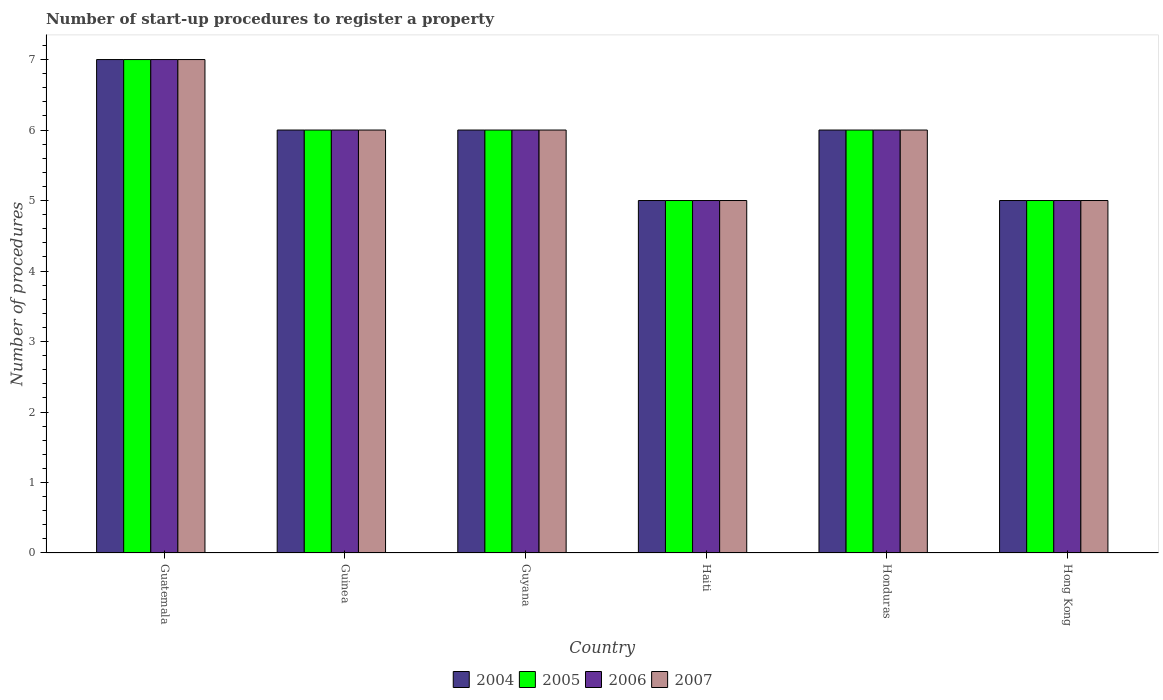How many different coloured bars are there?
Your answer should be very brief. 4. How many groups of bars are there?
Offer a very short reply. 6. Are the number of bars per tick equal to the number of legend labels?
Your answer should be compact. Yes. What is the label of the 5th group of bars from the left?
Provide a short and direct response. Honduras. In how many cases, is the number of bars for a given country not equal to the number of legend labels?
Your answer should be compact. 0. What is the number of procedures required to register a property in 2006 in Guyana?
Your response must be concise. 6. Across all countries, what is the minimum number of procedures required to register a property in 2007?
Your response must be concise. 5. In which country was the number of procedures required to register a property in 2004 maximum?
Make the answer very short. Guatemala. In which country was the number of procedures required to register a property in 2005 minimum?
Your response must be concise. Haiti. What is the average number of procedures required to register a property in 2004 per country?
Keep it short and to the point. 5.83. What is the difference between the number of procedures required to register a property of/in 2007 and number of procedures required to register a property of/in 2004 in Guyana?
Give a very brief answer. 0. What is the ratio of the number of procedures required to register a property in 2006 in Guyana to that in Haiti?
Make the answer very short. 1.2. Is the number of procedures required to register a property in 2007 in Haiti less than that in Hong Kong?
Keep it short and to the point. No. Is the difference between the number of procedures required to register a property in 2007 in Guinea and Honduras greater than the difference between the number of procedures required to register a property in 2004 in Guinea and Honduras?
Offer a terse response. No. Is the sum of the number of procedures required to register a property in 2006 in Guatemala and Hong Kong greater than the maximum number of procedures required to register a property in 2007 across all countries?
Provide a succinct answer. Yes. Is it the case that in every country, the sum of the number of procedures required to register a property in 2006 and number of procedures required to register a property in 2004 is greater than the sum of number of procedures required to register a property in 2007 and number of procedures required to register a property in 2005?
Your answer should be very brief. No. Are all the bars in the graph horizontal?
Your answer should be very brief. No. Does the graph contain any zero values?
Ensure brevity in your answer.  No. Does the graph contain grids?
Provide a short and direct response. No. Where does the legend appear in the graph?
Offer a terse response. Bottom center. How are the legend labels stacked?
Provide a succinct answer. Horizontal. What is the title of the graph?
Your response must be concise. Number of start-up procedures to register a property. What is the label or title of the Y-axis?
Provide a succinct answer. Number of procedures. What is the Number of procedures of 2005 in Guatemala?
Make the answer very short. 7. What is the Number of procedures of 2006 in Guatemala?
Provide a short and direct response. 7. What is the Number of procedures in 2004 in Guinea?
Your answer should be very brief. 6. What is the Number of procedures of 2005 in Guinea?
Keep it short and to the point. 6. What is the Number of procedures of 2006 in Guinea?
Your response must be concise. 6. What is the Number of procedures of 2007 in Guinea?
Keep it short and to the point. 6. What is the Number of procedures of 2005 in Guyana?
Offer a terse response. 6. What is the Number of procedures of 2006 in Guyana?
Your answer should be compact. 6. What is the Number of procedures of 2004 in Haiti?
Offer a terse response. 5. What is the Number of procedures of 2006 in Haiti?
Provide a short and direct response. 5. What is the Number of procedures of 2007 in Haiti?
Your answer should be compact. 5. What is the Number of procedures in 2006 in Honduras?
Provide a succinct answer. 6. What is the Number of procedures in 2005 in Hong Kong?
Your response must be concise. 5. What is the Number of procedures in 2007 in Hong Kong?
Offer a very short reply. 5. Across all countries, what is the maximum Number of procedures in 2004?
Offer a very short reply. 7. Across all countries, what is the maximum Number of procedures of 2005?
Offer a very short reply. 7. Across all countries, what is the maximum Number of procedures of 2006?
Offer a very short reply. 7. Across all countries, what is the maximum Number of procedures in 2007?
Offer a terse response. 7. Across all countries, what is the minimum Number of procedures of 2006?
Give a very brief answer. 5. What is the total Number of procedures in 2004 in the graph?
Your answer should be compact. 35. What is the total Number of procedures of 2005 in the graph?
Offer a terse response. 35. What is the difference between the Number of procedures of 2004 in Guatemala and that in Guinea?
Provide a short and direct response. 1. What is the difference between the Number of procedures of 2005 in Guatemala and that in Guinea?
Provide a short and direct response. 1. What is the difference between the Number of procedures in 2006 in Guatemala and that in Guinea?
Offer a very short reply. 1. What is the difference between the Number of procedures of 2007 in Guatemala and that in Guinea?
Provide a short and direct response. 1. What is the difference between the Number of procedures of 2005 in Guatemala and that in Guyana?
Your response must be concise. 1. What is the difference between the Number of procedures in 2006 in Guatemala and that in Guyana?
Provide a succinct answer. 1. What is the difference between the Number of procedures of 2006 in Guatemala and that in Haiti?
Your answer should be very brief. 2. What is the difference between the Number of procedures in 2007 in Guatemala and that in Haiti?
Offer a terse response. 2. What is the difference between the Number of procedures of 2004 in Guatemala and that in Honduras?
Offer a very short reply. 1. What is the difference between the Number of procedures in 2005 in Guatemala and that in Honduras?
Offer a very short reply. 1. What is the difference between the Number of procedures in 2006 in Guatemala and that in Honduras?
Your answer should be compact. 1. What is the difference between the Number of procedures of 2007 in Guatemala and that in Honduras?
Your answer should be very brief. 1. What is the difference between the Number of procedures of 2005 in Guatemala and that in Hong Kong?
Provide a succinct answer. 2. What is the difference between the Number of procedures in 2006 in Guatemala and that in Hong Kong?
Ensure brevity in your answer.  2. What is the difference between the Number of procedures in 2007 in Guatemala and that in Hong Kong?
Provide a short and direct response. 2. What is the difference between the Number of procedures of 2004 in Guinea and that in Guyana?
Your response must be concise. 0. What is the difference between the Number of procedures in 2005 in Guinea and that in Guyana?
Offer a very short reply. 0. What is the difference between the Number of procedures of 2007 in Guinea and that in Guyana?
Provide a short and direct response. 0. What is the difference between the Number of procedures of 2007 in Guinea and that in Haiti?
Offer a very short reply. 1. What is the difference between the Number of procedures of 2004 in Guinea and that in Honduras?
Your answer should be compact. 0. What is the difference between the Number of procedures of 2005 in Guinea and that in Honduras?
Your answer should be very brief. 0. What is the difference between the Number of procedures of 2006 in Guinea and that in Honduras?
Give a very brief answer. 0. What is the difference between the Number of procedures of 2005 in Guinea and that in Hong Kong?
Give a very brief answer. 1. What is the difference between the Number of procedures of 2005 in Guyana and that in Haiti?
Offer a terse response. 1. What is the difference between the Number of procedures in 2006 in Guyana and that in Haiti?
Your answer should be compact. 1. What is the difference between the Number of procedures of 2007 in Guyana and that in Haiti?
Offer a very short reply. 1. What is the difference between the Number of procedures of 2006 in Guyana and that in Honduras?
Provide a succinct answer. 0. What is the difference between the Number of procedures in 2004 in Guyana and that in Hong Kong?
Provide a short and direct response. 1. What is the difference between the Number of procedures of 2004 in Haiti and that in Honduras?
Make the answer very short. -1. What is the difference between the Number of procedures in 2005 in Haiti and that in Honduras?
Your response must be concise. -1. What is the difference between the Number of procedures of 2007 in Haiti and that in Hong Kong?
Provide a short and direct response. 0. What is the difference between the Number of procedures in 2004 in Honduras and that in Hong Kong?
Provide a succinct answer. 1. What is the difference between the Number of procedures in 2006 in Honduras and that in Hong Kong?
Your answer should be very brief. 1. What is the difference between the Number of procedures of 2007 in Honduras and that in Hong Kong?
Provide a succinct answer. 1. What is the difference between the Number of procedures in 2004 in Guatemala and the Number of procedures in 2006 in Guinea?
Keep it short and to the point. 1. What is the difference between the Number of procedures in 2005 in Guatemala and the Number of procedures in 2006 in Guinea?
Offer a terse response. 1. What is the difference between the Number of procedures in 2004 in Guatemala and the Number of procedures in 2005 in Guyana?
Ensure brevity in your answer.  1. What is the difference between the Number of procedures in 2005 in Guatemala and the Number of procedures in 2007 in Guyana?
Your answer should be very brief. 1. What is the difference between the Number of procedures in 2006 in Guatemala and the Number of procedures in 2007 in Guyana?
Provide a succinct answer. 1. What is the difference between the Number of procedures in 2004 in Guatemala and the Number of procedures in 2006 in Haiti?
Make the answer very short. 2. What is the difference between the Number of procedures in 2004 in Guatemala and the Number of procedures in 2007 in Haiti?
Ensure brevity in your answer.  2. What is the difference between the Number of procedures in 2005 in Guatemala and the Number of procedures in 2007 in Haiti?
Make the answer very short. 2. What is the difference between the Number of procedures in 2004 in Guatemala and the Number of procedures in 2006 in Honduras?
Keep it short and to the point. 1. What is the difference between the Number of procedures in 2004 in Guatemala and the Number of procedures in 2007 in Honduras?
Make the answer very short. 1. What is the difference between the Number of procedures of 2005 in Guatemala and the Number of procedures of 2007 in Honduras?
Make the answer very short. 1. What is the difference between the Number of procedures in 2006 in Guatemala and the Number of procedures in 2007 in Honduras?
Your response must be concise. 1. What is the difference between the Number of procedures in 2005 in Guatemala and the Number of procedures in 2006 in Hong Kong?
Give a very brief answer. 2. What is the difference between the Number of procedures of 2006 in Guatemala and the Number of procedures of 2007 in Hong Kong?
Your response must be concise. 2. What is the difference between the Number of procedures of 2004 in Guinea and the Number of procedures of 2005 in Guyana?
Your answer should be very brief. 0. What is the difference between the Number of procedures of 2004 in Guinea and the Number of procedures of 2007 in Guyana?
Offer a very short reply. 0. What is the difference between the Number of procedures in 2005 in Guinea and the Number of procedures in 2006 in Guyana?
Provide a succinct answer. 0. What is the difference between the Number of procedures of 2006 in Guinea and the Number of procedures of 2007 in Guyana?
Make the answer very short. 0. What is the difference between the Number of procedures of 2004 in Guinea and the Number of procedures of 2005 in Haiti?
Offer a very short reply. 1. What is the difference between the Number of procedures in 2004 in Guinea and the Number of procedures in 2007 in Haiti?
Your answer should be very brief. 1. What is the difference between the Number of procedures of 2005 in Guinea and the Number of procedures of 2006 in Haiti?
Your response must be concise. 1. What is the difference between the Number of procedures of 2005 in Guinea and the Number of procedures of 2007 in Haiti?
Keep it short and to the point. 1. What is the difference between the Number of procedures of 2004 in Guinea and the Number of procedures of 2005 in Honduras?
Ensure brevity in your answer.  0. What is the difference between the Number of procedures of 2004 in Guinea and the Number of procedures of 2006 in Honduras?
Ensure brevity in your answer.  0. What is the difference between the Number of procedures of 2004 in Guinea and the Number of procedures of 2007 in Honduras?
Ensure brevity in your answer.  0. What is the difference between the Number of procedures in 2005 in Guinea and the Number of procedures in 2007 in Honduras?
Offer a terse response. 0. What is the difference between the Number of procedures of 2005 in Guinea and the Number of procedures of 2006 in Hong Kong?
Offer a very short reply. 1. What is the difference between the Number of procedures of 2005 in Guinea and the Number of procedures of 2007 in Hong Kong?
Make the answer very short. 1. What is the difference between the Number of procedures of 2006 in Guyana and the Number of procedures of 2007 in Haiti?
Your answer should be very brief. 1. What is the difference between the Number of procedures in 2004 in Guyana and the Number of procedures in 2006 in Honduras?
Your response must be concise. 0. What is the difference between the Number of procedures of 2004 in Guyana and the Number of procedures of 2007 in Hong Kong?
Your answer should be compact. 1. What is the difference between the Number of procedures of 2005 in Guyana and the Number of procedures of 2006 in Hong Kong?
Provide a succinct answer. 1. What is the difference between the Number of procedures of 2004 in Haiti and the Number of procedures of 2005 in Honduras?
Ensure brevity in your answer.  -1. What is the difference between the Number of procedures of 2005 in Haiti and the Number of procedures of 2006 in Honduras?
Ensure brevity in your answer.  -1. What is the difference between the Number of procedures in 2005 in Haiti and the Number of procedures in 2007 in Honduras?
Make the answer very short. -1. What is the difference between the Number of procedures in 2005 in Haiti and the Number of procedures in 2006 in Hong Kong?
Keep it short and to the point. 0. What is the difference between the Number of procedures of 2005 in Haiti and the Number of procedures of 2007 in Hong Kong?
Keep it short and to the point. 0. What is the difference between the Number of procedures in 2004 in Honduras and the Number of procedures in 2007 in Hong Kong?
Your answer should be compact. 1. What is the difference between the Number of procedures of 2006 in Honduras and the Number of procedures of 2007 in Hong Kong?
Provide a succinct answer. 1. What is the average Number of procedures of 2004 per country?
Your response must be concise. 5.83. What is the average Number of procedures in 2005 per country?
Provide a succinct answer. 5.83. What is the average Number of procedures in 2006 per country?
Your answer should be compact. 5.83. What is the average Number of procedures in 2007 per country?
Ensure brevity in your answer.  5.83. What is the difference between the Number of procedures of 2004 and Number of procedures of 2005 in Guatemala?
Your answer should be compact. 0. What is the difference between the Number of procedures in 2004 and Number of procedures in 2007 in Guatemala?
Keep it short and to the point. 0. What is the difference between the Number of procedures in 2005 and Number of procedures in 2006 in Guatemala?
Offer a very short reply. 0. What is the difference between the Number of procedures of 2005 and Number of procedures of 2007 in Guatemala?
Keep it short and to the point. 0. What is the difference between the Number of procedures in 2004 and Number of procedures in 2005 in Guinea?
Offer a very short reply. 0. What is the difference between the Number of procedures of 2004 and Number of procedures of 2006 in Guinea?
Offer a terse response. 0. What is the difference between the Number of procedures of 2004 and Number of procedures of 2007 in Guinea?
Keep it short and to the point. 0. What is the difference between the Number of procedures in 2005 and Number of procedures in 2007 in Guinea?
Your answer should be very brief. 0. What is the difference between the Number of procedures in 2004 and Number of procedures in 2005 in Guyana?
Give a very brief answer. 0. What is the difference between the Number of procedures in 2005 and Number of procedures in 2007 in Guyana?
Offer a terse response. 0. What is the difference between the Number of procedures in 2006 and Number of procedures in 2007 in Guyana?
Your response must be concise. 0. What is the difference between the Number of procedures of 2004 and Number of procedures of 2005 in Haiti?
Offer a terse response. 0. What is the difference between the Number of procedures in 2004 and Number of procedures in 2007 in Haiti?
Ensure brevity in your answer.  0. What is the difference between the Number of procedures in 2005 and Number of procedures in 2006 in Haiti?
Offer a terse response. 0. What is the difference between the Number of procedures in 2005 and Number of procedures in 2007 in Haiti?
Make the answer very short. 0. What is the difference between the Number of procedures of 2004 and Number of procedures of 2005 in Hong Kong?
Offer a very short reply. 0. What is the difference between the Number of procedures in 2004 and Number of procedures in 2006 in Hong Kong?
Ensure brevity in your answer.  0. What is the difference between the Number of procedures in 2004 and Number of procedures in 2007 in Hong Kong?
Make the answer very short. 0. What is the ratio of the Number of procedures in 2004 in Guatemala to that in Guinea?
Your answer should be very brief. 1.17. What is the ratio of the Number of procedures in 2006 in Guatemala to that in Guinea?
Offer a very short reply. 1.17. What is the ratio of the Number of procedures of 2007 in Guatemala to that in Guinea?
Provide a succinct answer. 1.17. What is the ratio of the Number of procedures in 2004 in Guatemala to that in Guyana?
Make the answer very short. 1.17. What is the ratio of the Number of procedures of 2005 in Guatemala to that in Guyana?
Offer a very short reply. 1.17. What is the ratio of the Number of procedures of 2006 in Guatemala to that in Guyana?
Ensure brevity in your answer.  1.17. What is the ratio of the Number of procedures in 2007 in Guatemala to that in Guyana?
Offer a terse response. 1.17. What is the ratio of the Number of procedures in 2005 in Guatemala to that in Haiti?
Give a very brief answer. 1.4. What is the ratio of the Number of procedures in 2006 in Guatemala to that in Haiti?
Your response must be concise. 1.4. What is the ratio of the Number of procedures in 2007 in Guatemala to that in Haiti?
Give a very brief answer. 1.4. What is the ratio of the Number of procedures of 2004 in Guatemala to that in Honduras?
Keep it short and to the point. 1.17. What is the ratio of the Number of procedures in 2004 in Guatemala to that in Hong Kong?
Keep it short and to the point. 1.4. What is the ratio of the Number of procedures of 2007 in Guatemala to that in Hong Kong?
Keep it short and to the point. 1.4. What is the ratio of the Number of procedures of 2005 in Guinea to that in Guyana?
Your answer should be very brief. 1. What is the ratio of the Number of procedures of 2005 in Guinea to that in Haiti?
Your answer should be compact. 1.2. What is the ratio of the Number of procedures of 2004 in Guinea to that in Honduras?
Offer a very short reply. 1. What is the ratio of the Number of procedures in 2004 in Guinea to that in Hong Kong?
Keep it short and to the point. 1.2. What is the ratio of the Number of procedures in 2006 in Guinea to that in Hong Kong?
Ensure brevity in your answer.  1.2. What is the ratio of the Number of procedures in 2007 in Guinea to that in Hong Kong?
Keep it short and to the point. 1.2. What is the ratio of the Number of procedures of 2004 in Guyana to that in Haiti?
Make the answer very short. 1.2. What is the ratio of the Number of procedures in 2005 in Guyana to that in Haiti?
Give a very brief answer. 1.2. What is the ratio of the Number of procedures in 2007 in Guyana to that in Haiti?
Your answer should be compact. 1.2. What is the ratio of the Number of procedures of 2004 in Guyana to that in Honduras?
Offer a terse response. 1. What is the ratio of the Number of procedures in 2005 in Guyana to that in Honduras?
Make the answer very short. 1. What is the ratio of the Number of procedures in 2006 in Guyana to that in Honduras?
Provide a short and direct response. 1. What is the ratio of the Number of procedures of 2007 in Guyana to that in Honduras?
Offer a very short reply. 1. What is the ratio of the Number of procedures in 2005 in Guyana to that in Hong Kong?
Ensure brevity in your answer.  1.2. What is the ratio of the Number of procedures in 2007 in Haiti to that in Honduras?
Give a very brief answer. 0.83. What is the ratio of the Number of procedures in 2004 in Haiti to that in Hong Kong?
Provide a short and direct response. 1. What is the ratio of the Number of procedures in 2005 in Haiti to that in Hong Kong?
Your response must be concise. 1. What is the ratio of the Number of procedures of 2006 in Haiti to that in Hong Kong?
Your answer should be very brief. 1. What is the ratio of the Number of procedures of 2007 in Haiti to that in Hong Kong?
Your response must be concise. 1. What is the ratio of the Number of procedures of 2004 in Honduras to that in Hong Kong?
Keep it short and to the point. 1.2. What is the ratio of the Number of procedures of 2006 in Honduras to that in Hong Kong?
Ensure brevity in your answer.  1.2. What is the difference between the highest and the second highest Number of procedures of 2004?
Make the answer very short. 1. What is the difference between the highest and the second highest Number of procedures of 2007?
Offer a very short reply. 1. What is the difference between the highest and the lowest Number of procedures in 2004?
Offer a very short reply. 2. What is the difference between the highest and the lowest Number of procedures in 2007?
Give a very brief answer. 2. 